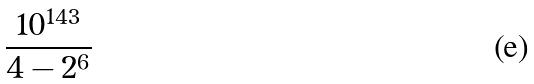<formula> <loc_0><loc_0><loc_500><loc_500>\frac { 1 0 ^ { 1 4 3 } } { 4 - 2 ^ { 6 } }</formula> 